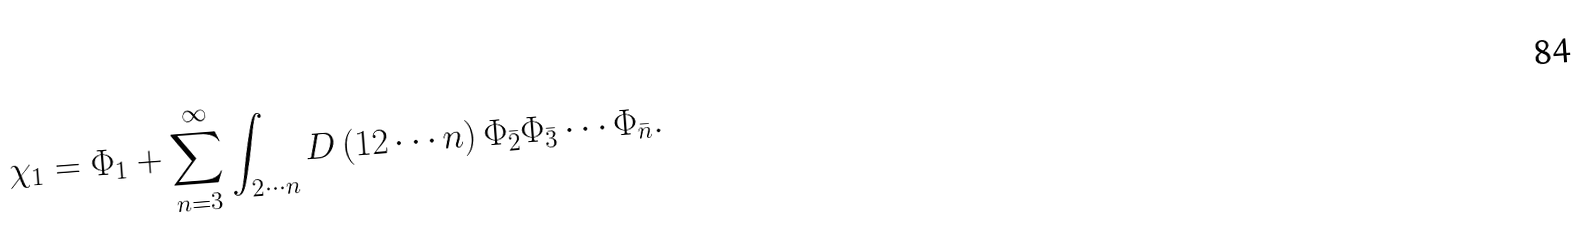Convert formula to latex. <formula><loc_0><loc_0><loc_500><loc_500>\chi _ { 1 } = \Phi _ { 1 } + \sum _ { n = 3 } ^ { \infty } \int _ { 2 \cdots n } D \left ( 1 2 \cdots n \right ) \Phi _ { \bar { 2 } } \Phi _ { \bar { 3 } } \cdots \Phi _ { \bar { n } } .</formula> 